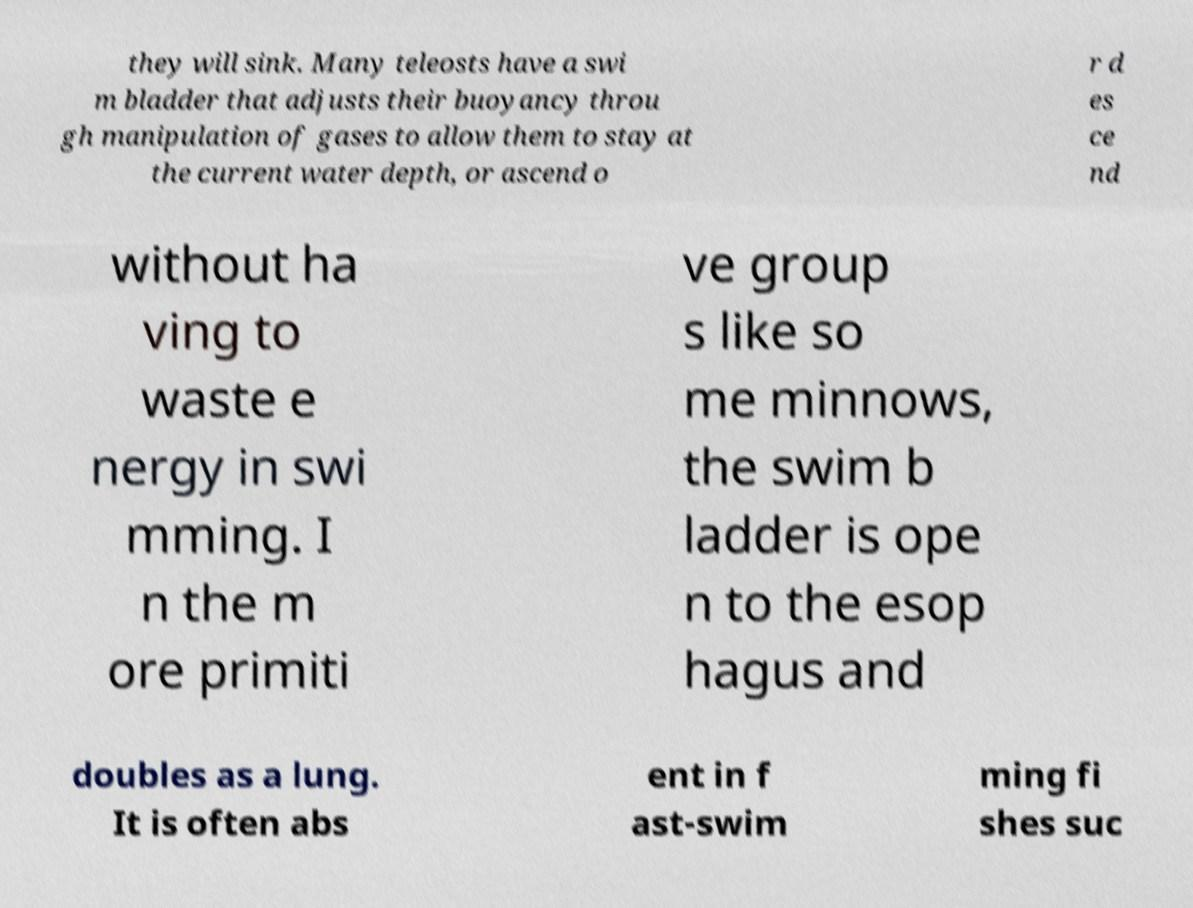I need the written content from this picture converted into text. Can you do that? they will sink. Many teleosts have a swi m bladder that adjusts their buoyancy throu gh manipulation of gases to allow them to stay at the current water depth, or ascend o r d es ce nd without ha ving to waste e nergy in swi mming. I n the m ore primiti ve group s like so me minnows, the swim b ladder is ope n to the esop hagus and doubles as a lung. It is often abs ent in f ast-swim ming fi shes suc 